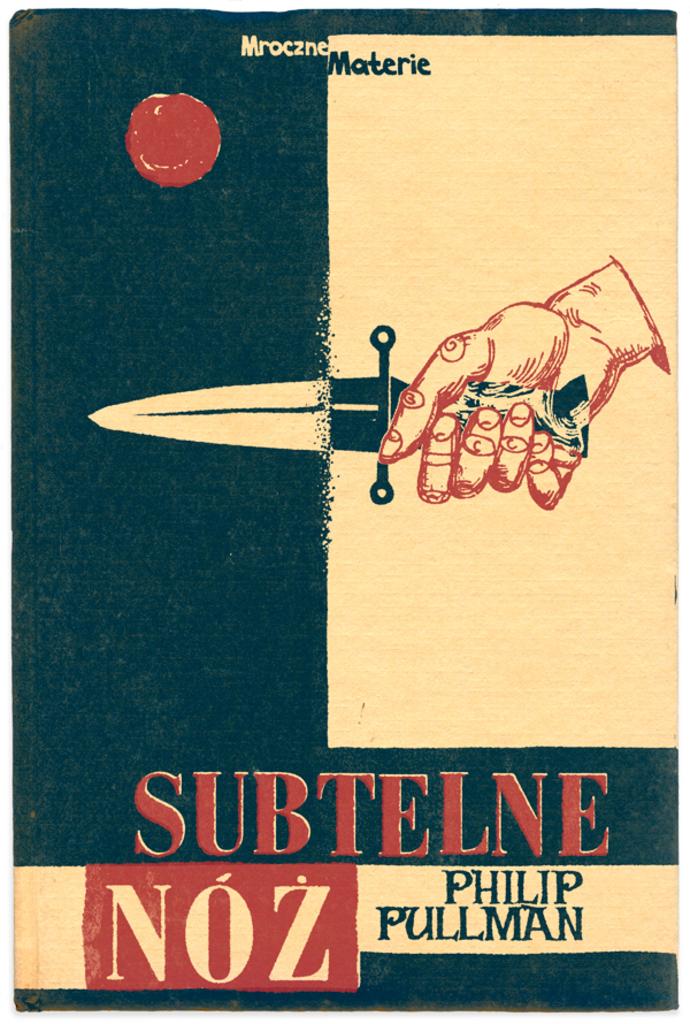What is the author's name?
Your response must be concise. Philip pullman. What is the title of this?
Offer a very short reply. Subtelne noz. 